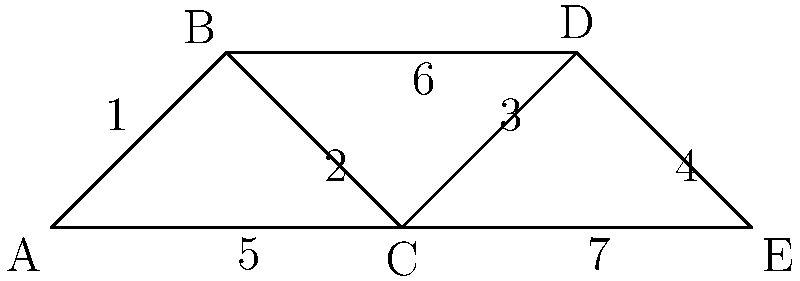In the pharmaceutical distribution network shown above, nodes represent different entities (A: Manufacturer, B: Wholesaler, C: Distributor, D: Pharmacy, E: Patient), and edges represent distribution channels. If edge 3 (between C and D) is removed due to regulatory issues, what is the minimum number of additional edges that need to be added to ensure that there is still a path from the manufacturer (A) to the patient (E)? To solve this problem, we need to analyze the connectivity of the network after removing edge 3:

1. Current paths from A to E:
   - A -> B -> C -> D -> E
   - A -> C -> D -> E
   - A -> C -> E

2. After removing edge 3 (C-D), the remaining paths are:
   - A -> C -> E

3. To ensure robustness and maintain alternative routes, we need to add edges that create new paths from A to E without using C-D.

4. The most efficient way to do this is by adding one edge that bypasses both C and D. 

5. The optimal edge to add would be B-E, as it creates a new short path:
   - A -> B -> E

6. This new edge ensures that there is still a path from the manufacturer (A) to the patient (E) even if the C-D connection is lost, and it provides an alternative route that doesn't rely on the distributor (C).

7. Therefore, the minimum number of additional edges needed is 1.
Answer: 1 